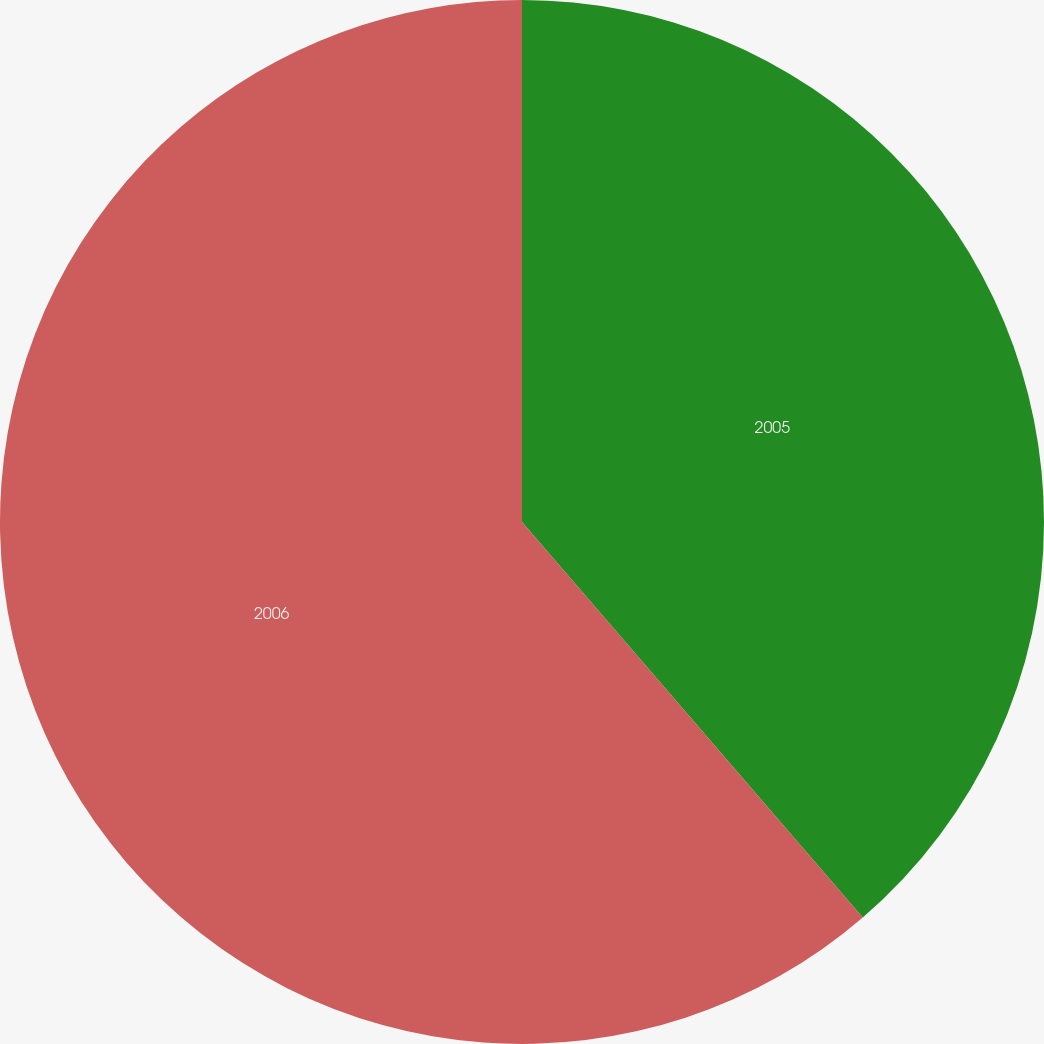<chart> <loc_0><loc_0><loc_500><loc_500><pie_chart><fcel>2005<fcel>2006<nl><fcel>38.68%<fcel>61.32%<nl></chart> 